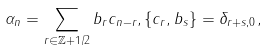Convert formula to latex. <formula><loc_0><loc_0><loc_500><loc_500>\alpha _ { n } = \sum _ { r \in { \mathbb { Z } } + 1 / 2 } b _ { r } c _ { n - r } , \{ c _ { r } , b _ { s } \} = \delta _ { r + s , 0 } ,</formula> 